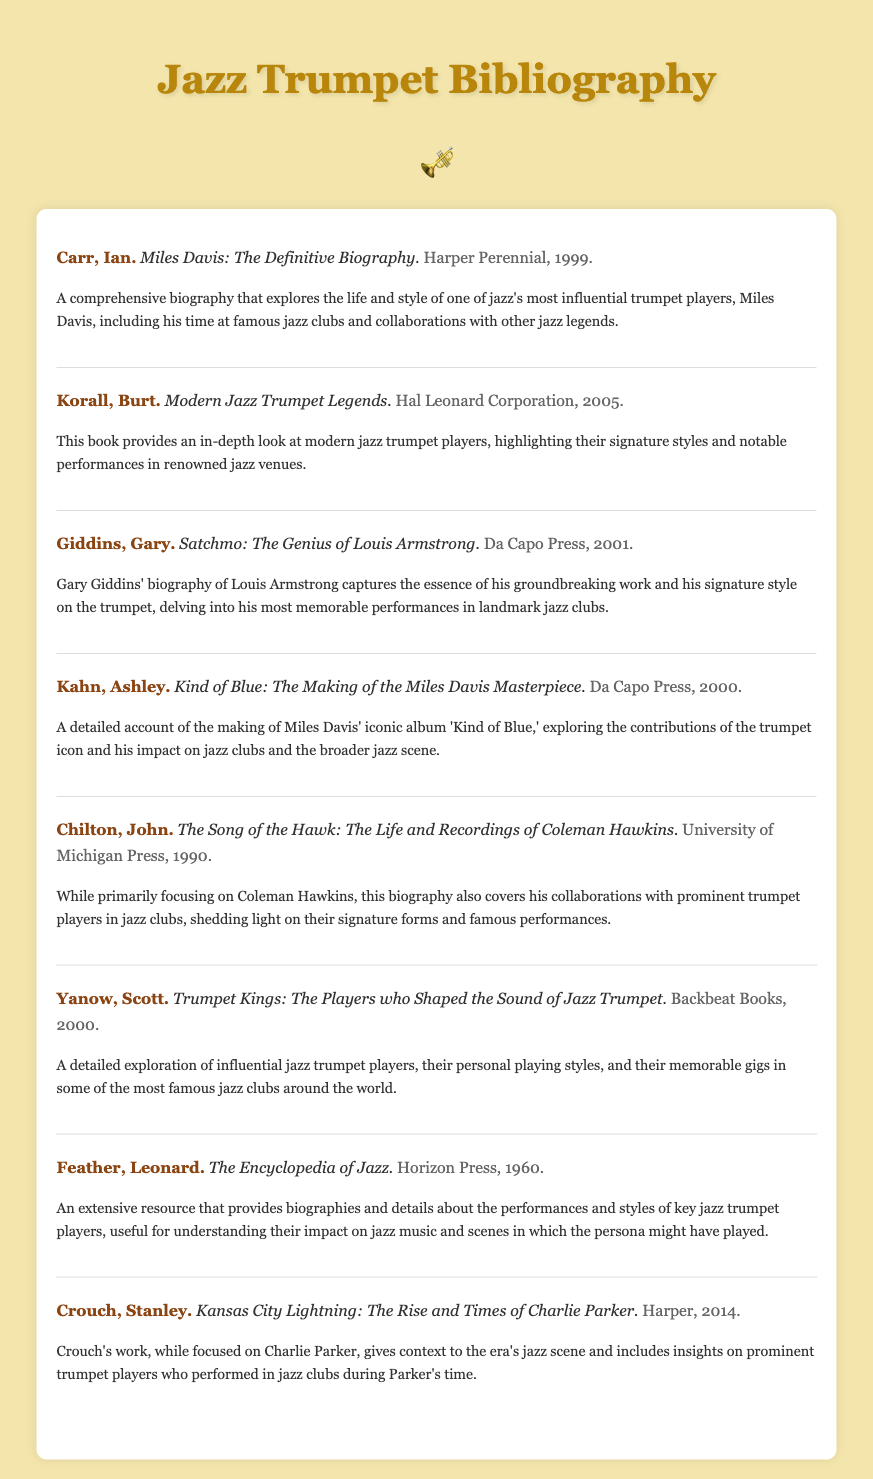What is the title of Ian Carr's biography? The title is listed in the bibliography entry, which states "Miles Davis: The Definitive Biography."
Answer: Miles Davis: The Definitive Biography Who is the author of "Modern Jazz Trumpet Legends"? The author of this title can be found in the bibliographic entry which mentions Burt Korall.
Answer: Burt Korall In what year was "Satchmo: The Genius of Louis Armstrong" published? The year of publication is noted in the entry for the book by Gary Giddins, which states 2001.
Answer: 2001 Which publisher released "Kind of Blue: The Making of the Miles Davis Masterpiece"? The publisher is specified in the bibliographic entry as Da Capo Press.
Answer: Da Capo Press How many entries are there in the bibliography? The total number of entries is determined by counting the individual entries listed, and there are eight.
Answer: 8 What genre does the bibliography focus on? The focus of the bibliography is noted in the title, which indicates that it is about jazz trumpet players.
Answer: Jazz trumpet players Which performance venue is frequently referenced in relation to the trumpet players? The performances are often associated with famous jazz clubs, as mentioned in multiple entries.
Answer: Famous jazz clubs What is a common theme among the biographies cited in the document? A recurring theme discussed throughout the document includes the influence and styles of each trumpet player in the jazz scene.
Answer: Influence and styles 